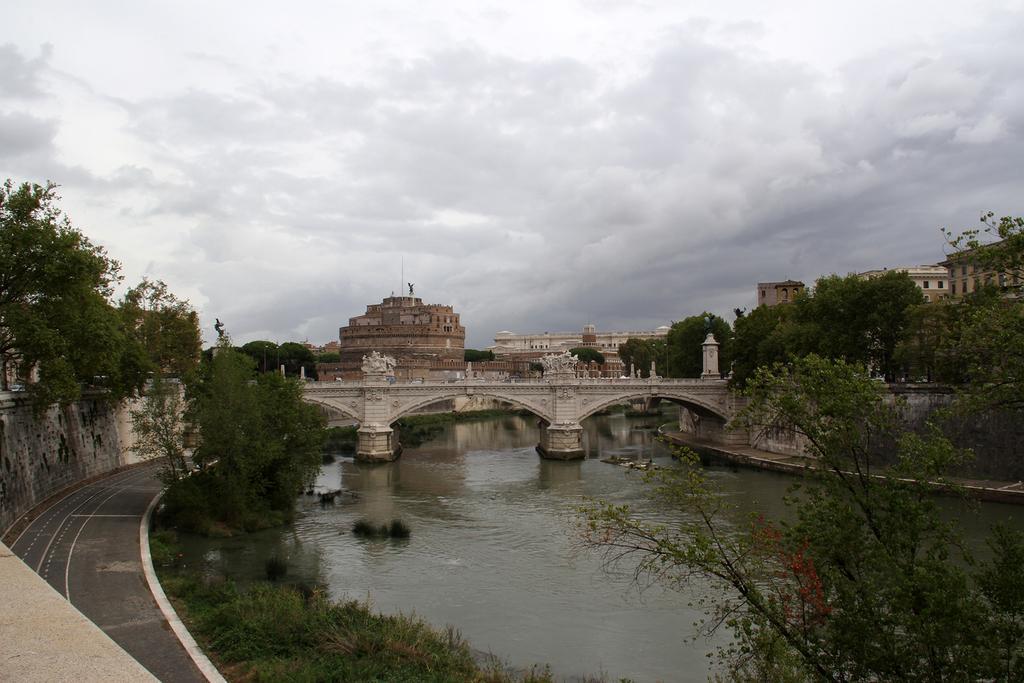Can you describe this image briefly? In this picture we can see some grass and plants on the ground. There are few trees and walls on the right and left side of the image. We can see a bridge and water. A path is visible on the left side. There are a few buildings visible in the background. Sky is cloudy. 